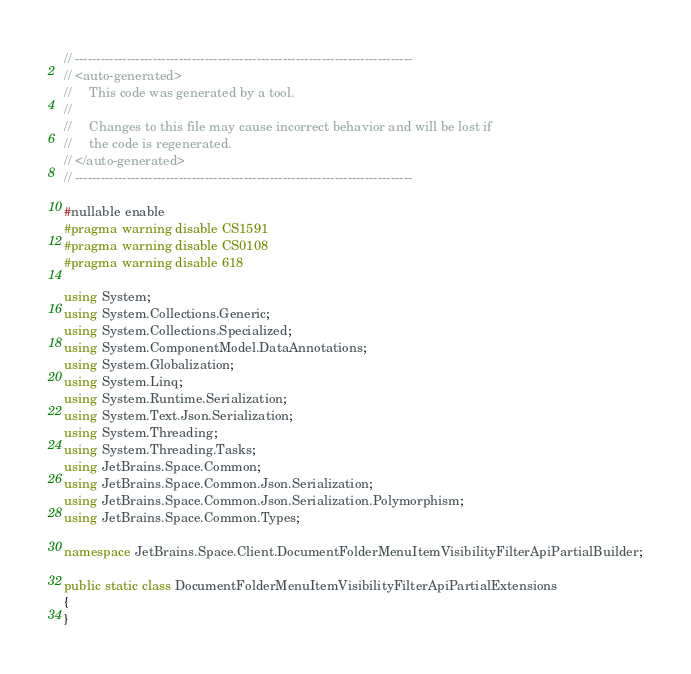Convert code to text. <code><loc_0><loc_0><loc_500><loc_500><_C#_>// ------------------------------------------------------------------------------
// <auto-generated>
//     This code was generated by a tool.
// 
//     Changes to this file may cause incorrect behavior and will be lost if
//     the code is regenerated.
// </auto-generated>
// ------------------------------------------------------------------------------

#nullable enable
#pragma warning disable CS1591
#pragma warning disable CS0108
#pragma warning disable 618

using System;
using System.Collections.Generic;
using System.Collections.Specialized;
using System.ComponentModel.DataAnnotations;
using System.Globalization;
using System.Linq;
using System.Runtime.Serialization;
using System.Text.Json.Serialization;
using System.Threading;
using System.Threading.Tasks;
using JetBrains.Space.Common;
using JetBrains.Space.Common.Json.Serialization;
using JetBrains.Space.Common.Json.Serialization.Polymorphism;
using JetBrains.Space.Common.Types;

namespace JetBrains.Space.Client.DocumentFolderMenuItemVisibilityFilterApiPartialBuilder;

public static class DocumentFolderMenuItemVisibilityFilterApiPartialExtensions
{
}

</code> 